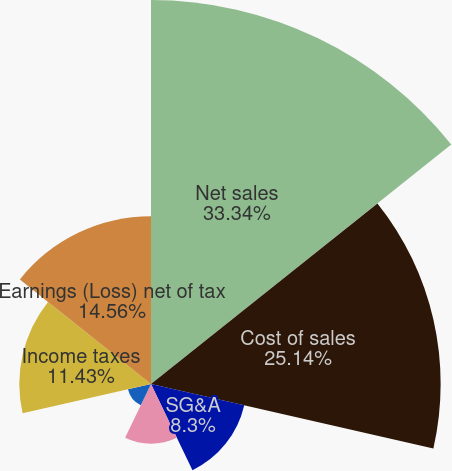Convert chart to OTSL. <chart><loc_0><loc_0><loc_500><loc_500><pie_chart><fcel>Net sales<fcel>Cost of sales<fcel>SG&A<fcel>Other deductions net<fcel>Earnings (Loss) before income<fcel>Income taxes<fcel>Earnings (Loss) net of tax<nl><fcel>33.33%<fcel>25.14%<fcel>8.3%<fcel>5.18%<fcel>2.05%<fcel>11.43%<fcel>14.56%<nl></chart> 